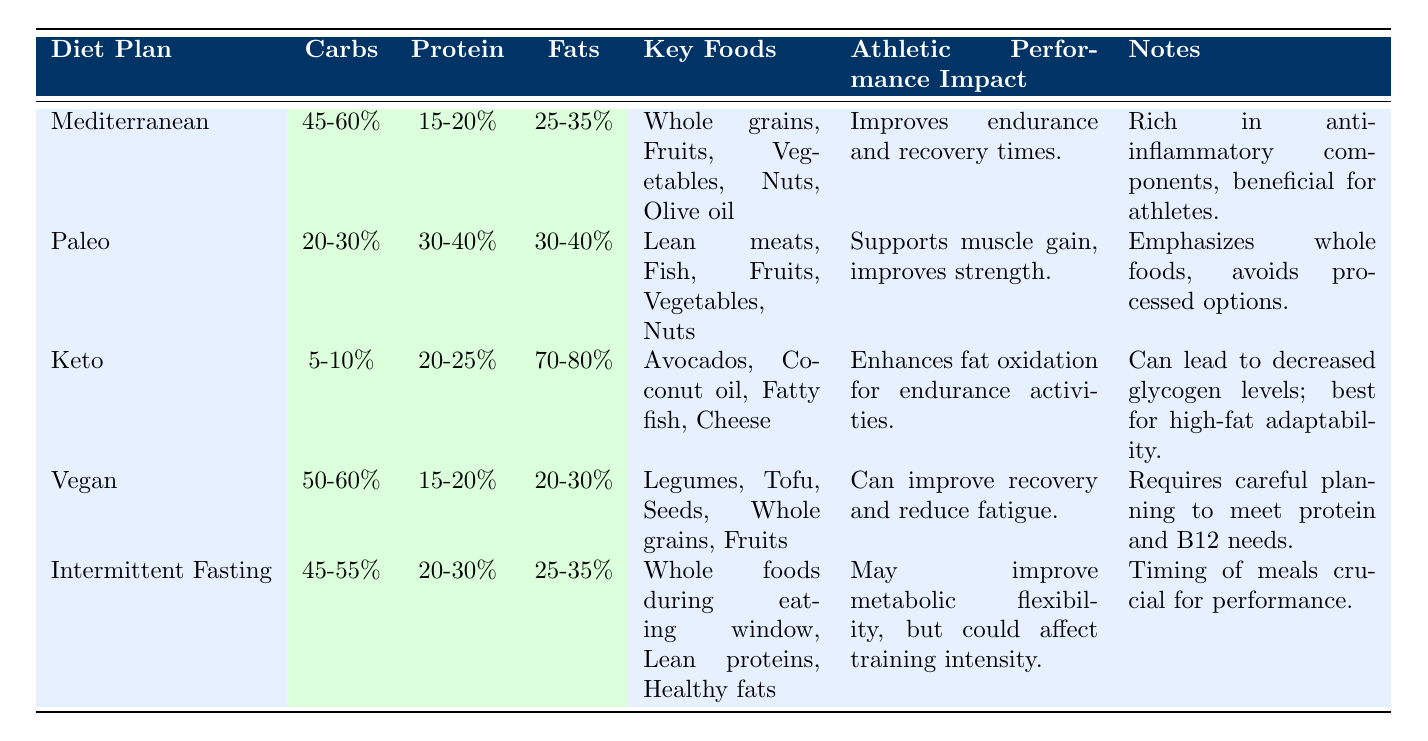What is the carbohydrate percentage range for the Mediterranean diet? The table lists the dietary components for each diet plan, which includes the carbohydrate percentage range for the Mediterranean diet as 45-60%.
Answer: 45-60% Which diet plan has the highest fat percentage? The Keto diet is specified in the table with a fat percentage range of 70-80%, making it the diet with the highest fat percentage.
Answer: Keto Is the Vegan diet rich in proteins? The table shows that the Vegan diet has a protein range of 15-20%, which is relatively lower compared to other diet plans. Therefore, the answer is no.
Answer: No What are the key foods included in the Paleo diet? Referring to the Paleo diet row, the key foods listed are Lean meats, Fish, Fruits, Vegetables, and Nuts, providing a complete answer for the question.
Answer: Lean meats, Fish, Fruits, Vegetables, Nuts For which diet plan is the recovery and fatigue improvement noted? The table states that the Vegan diet can improve recovery and reduce fatigue. Thus, looking at this row gives the answer directly from the table.
Answer: Vegan Which diet emphasizes whole foods and avoids processed options? According to the table, the Paleo diet emphasizes whole foods and avoids processed options, directly answering the question.
Answer: Paleo How does the Mediterranean diet impact athletic performance? The table notes that the Mediterranean diet improves endurance and recovery times, providing specific information on its effect on athletic performance.
Answer: Improves endurance and recovery times Which diet plans have a protein percentage of above 20%? The Paleo diet (30-40%) and Intermittent Fasting (20-30%) both have protein percentages above 20%. We refer to the respective rows for accurate filtering.
Answer: Paleo, Intermittent Fasting What is the average fat percentage of the Mediterranean and Vegan diets combined? The Mediterranean diet has a fat percentage of 25-35% and the Vegan diet has 20-30%. To find the average, we can take the midpoints: 30% for Mediterranean and 25% for Vegan, then calculate the average (30 + 25) / 2 = 27.5%.
Answer: 27.5% 